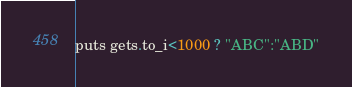<code> <loc_0><loc_0><loc_500><loc_500><_Ruby_>puts gets.to_i<1000 ? "ABC":"ABD"</code> 